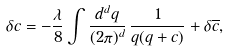Convert formula to latex. <formula><loc_0><loc_0><loc_500><loc_500>\delta c = - \frac { \lambda } { 8 } \int \frac { d ^ { d } q } { ( 2 \pi ) ^ { d } } \, \frac { 1 } { q ( q + c ) } + \delta \overline { c } ,</formula> 